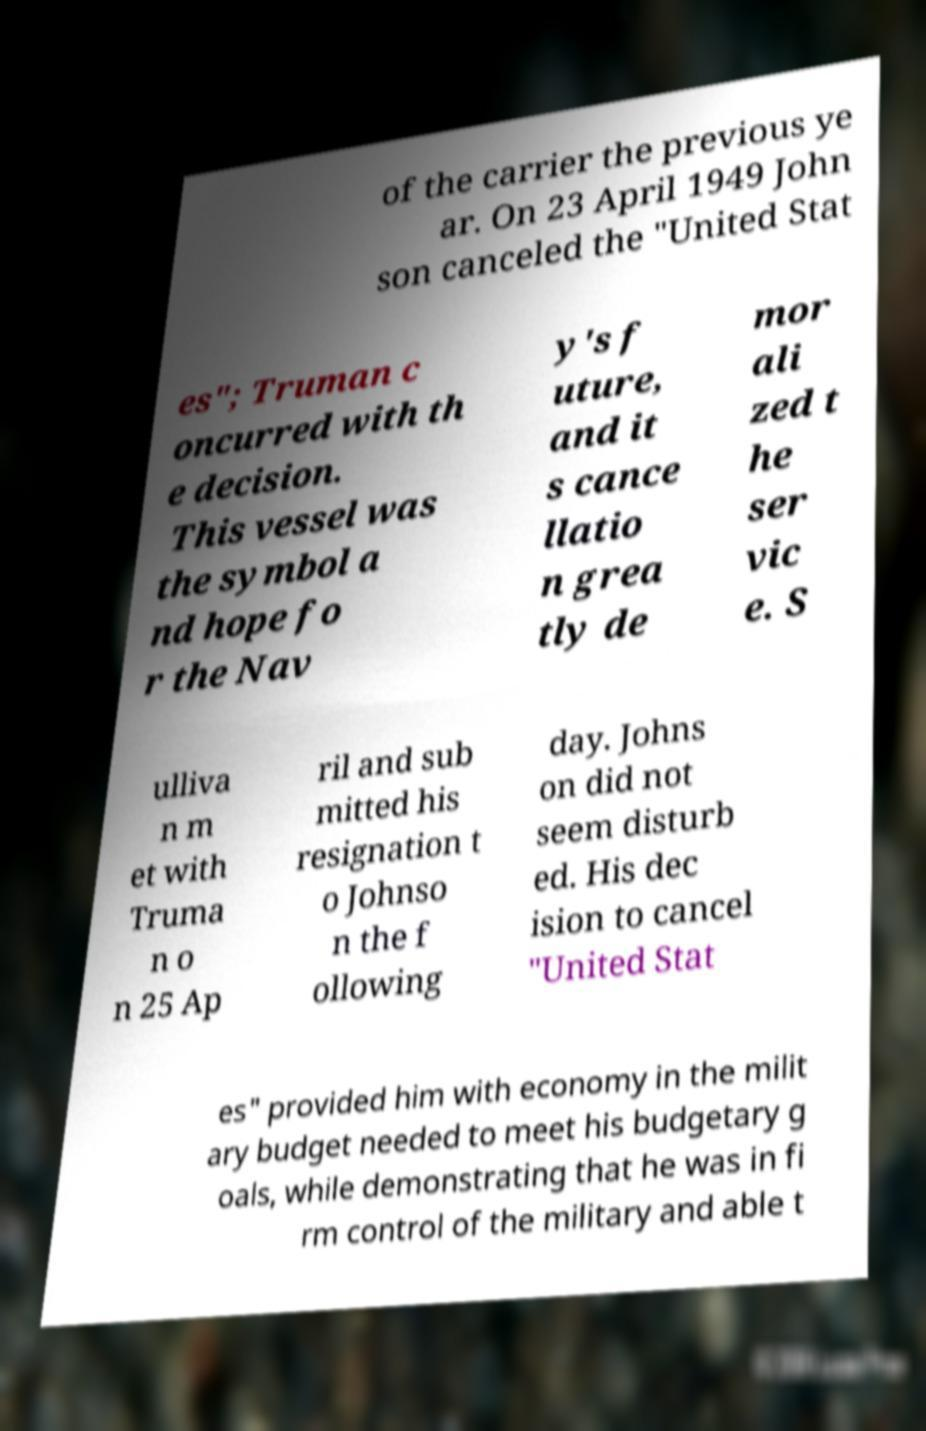Could you assist in decoding the text presented in this image and type it out clearly? of the carrier the previous ye ar. On 23 April 1949 John son canceled the "United Stat es"; Truman c oncurred with th e decision. This vessel was the symbol a nd hope fo r the Nav y's f uture, and it s cance llatio n grea tly de mor ali zed t he ser vic e. S ulliva n m et with Truma n o n 25 Ap ril and sub mitted his resignation t o Johnso n the f ollowing day. Johns on did not seem disturb ed. His dec ision to cancel "United Stat es" provided him with economy in the milit ary budget needed to meet his budgetary g oals, while demonstrating that he was in fi rm control of the military and able t 